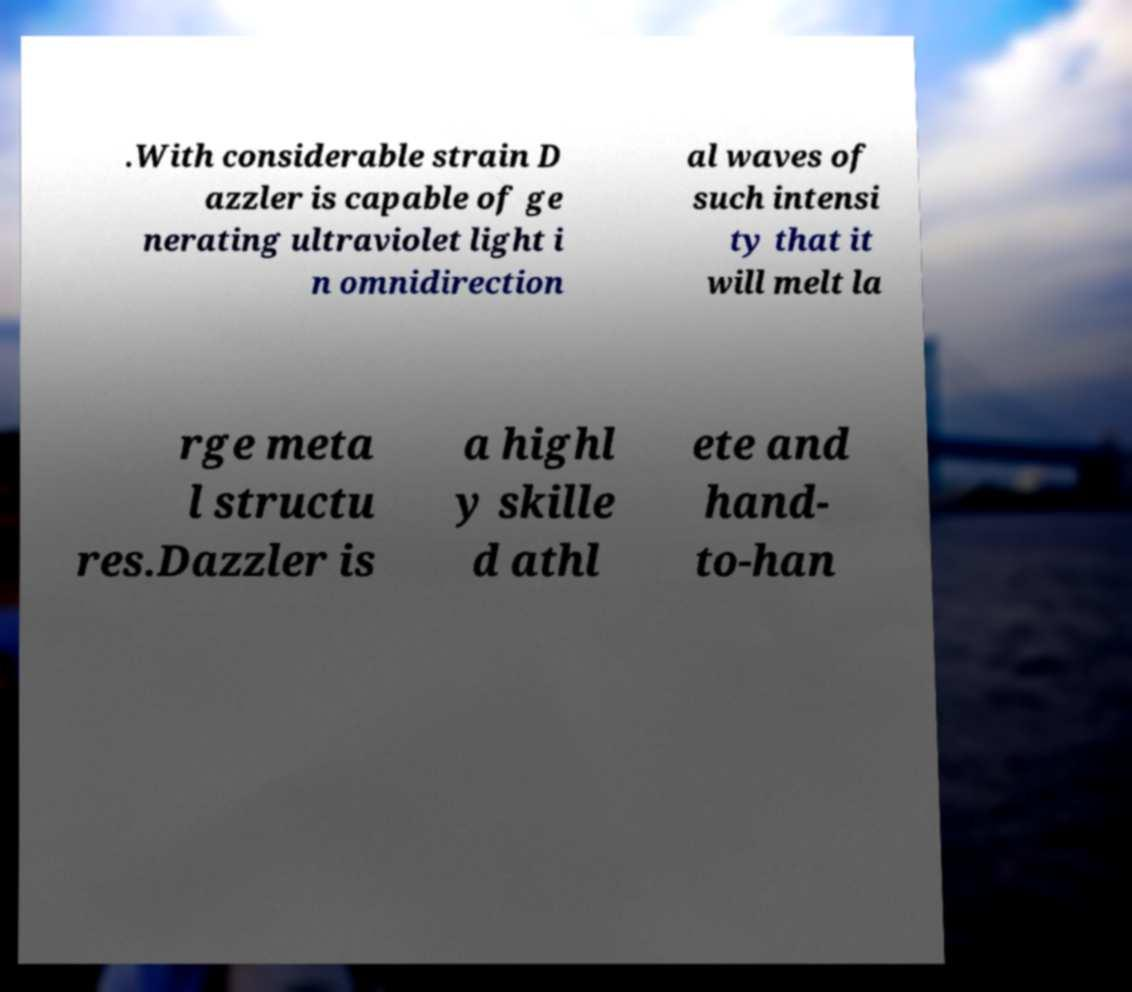There's text embedded in this image that I need extracted. Can you transcribe it verbatim? .With considerable strain D azzler is capable of ge nerating ultraviolet light i n omnidirection al waves of such intensi ty that it will melt la rge meta l structu res.Dazzler is a highl y skille d athl ete and hand- to-han 